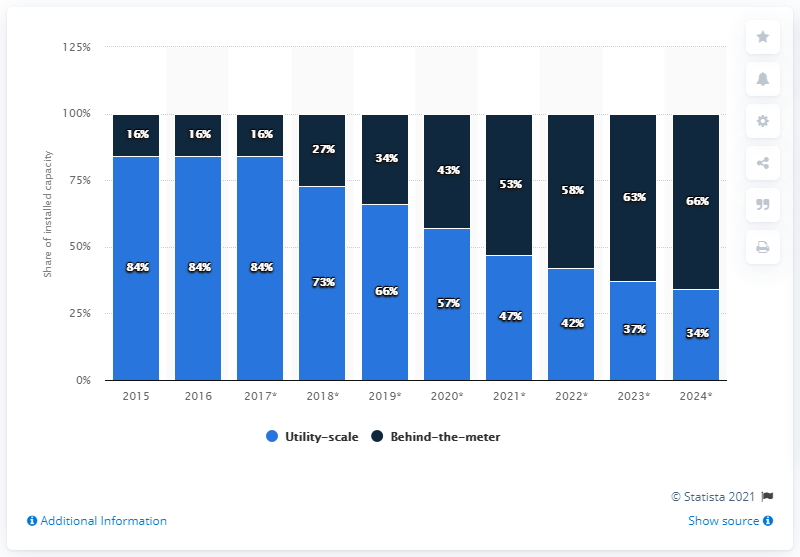Give some essential details in this illustration. Over the years, utility-scale solar photovoltaic systems have become increasingly popular, leading to a decrease in the use of fossil fuels for electricity generation. By 2024, it is projected that 34% of the total energy storage capacity worldwide will be utility-scale energy storage capacity. In 2021, which year has the smallest difference between the two factors? 